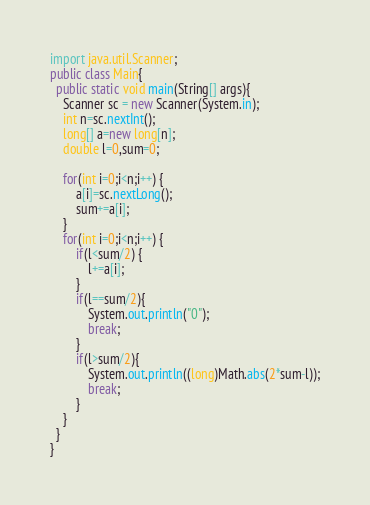Convert code to text. <code><loc_0><loc_0><loc_500><loc_500><_Java_>import java.util.Scanner;
public class Main{
  public static void main(String[] args){
    Scanner sc = new Scanner(System.in);
    int n=sc.nextInt();
    long[] a=new long[n];
    double l=0,sum=0;
    
    for(int i=0;i<n;i++) {
    	a[i]=sc.nextLong();
    	sum+=a[i];
    }
    for(int i=0;i<n;i++) {
    	if(l<sum/2) {
    		l+=a[i];
    	}
    	if(l==sum/2){
    		System.out.println("0");
    		break;
    	}
    	if(l>sum/2){
    		System.out.println((long)Math.abs(2*sum-l));
    		break;
    	}
    }
  }
}
</code> 